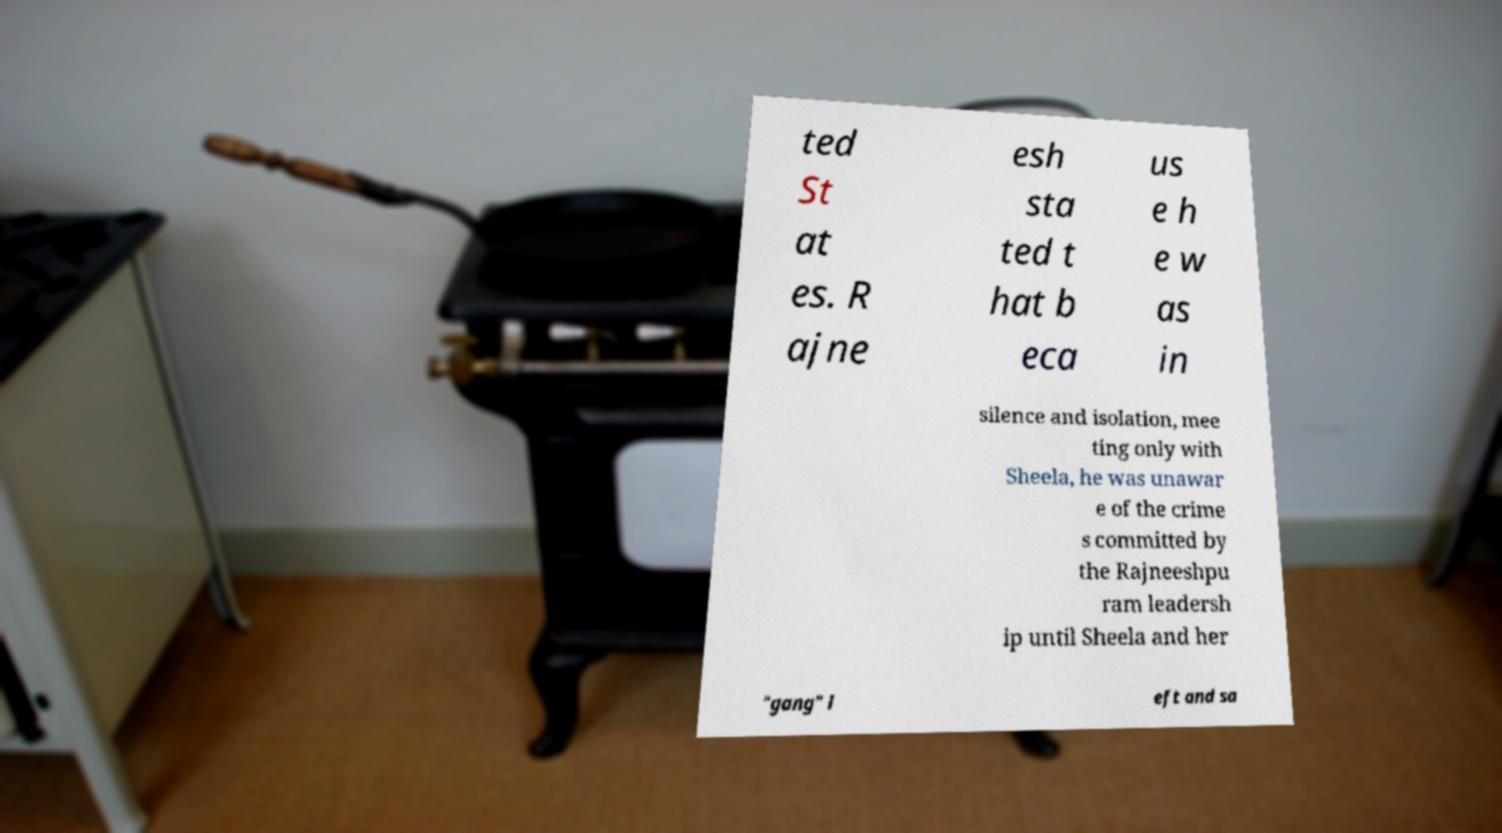Can you accurately transcribe the text from the provided image for me? ted St at es. R ajne esh sta ted t hat b eca us e h e w as in silence and isolation, mee ting only with Sheela, he was unawar e of the crime s committed by the Rajneeshpu ram leadersh ip until Sheela and her "gang" l eft and sa 